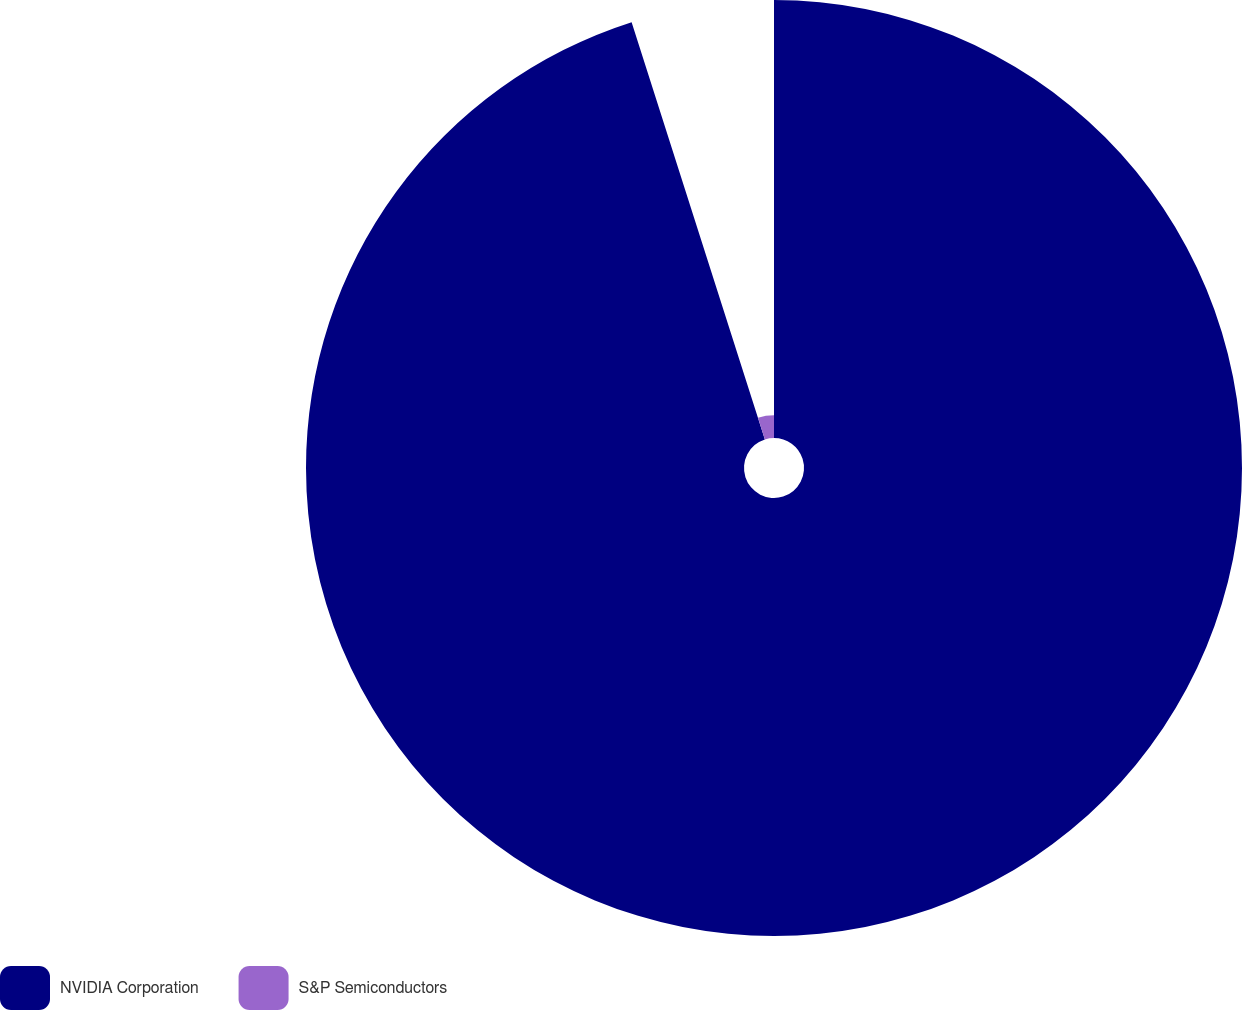<chart> <loc_0><loc_0><loc_500><loc_500><pie_chart><fcel>NVIDIA Corporation<fcel>S&P Semiconductors<nl><fcel>95.08%<fcel>4.92%<nl></chart> 